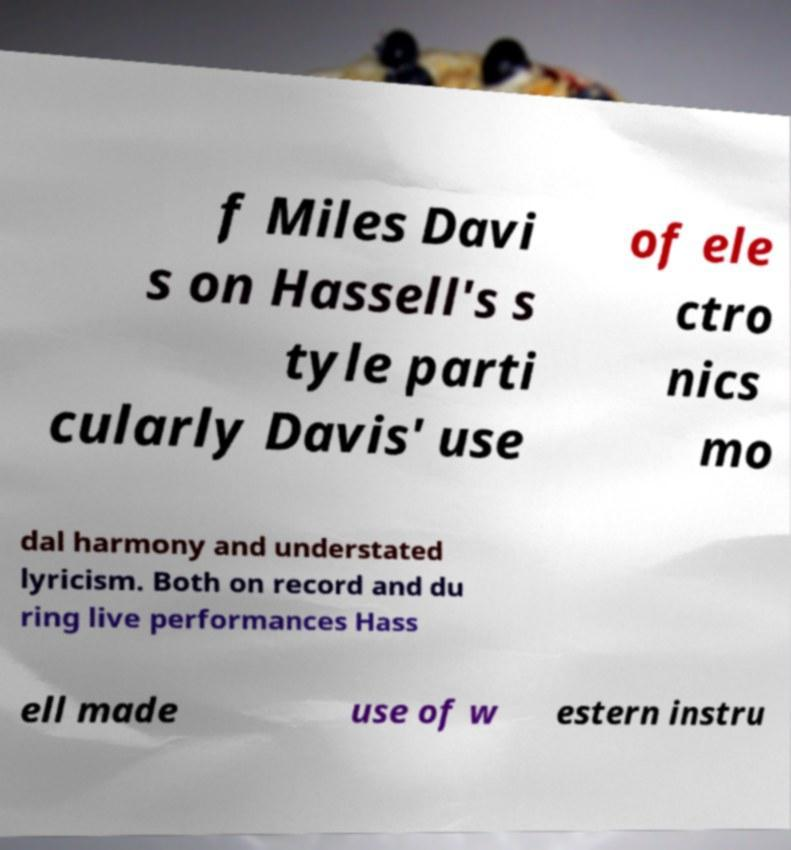Please read and relay the text visible in this image. What does it say? f Miles Davi s on Hassell's s tyle parti cularly Davis' use of ele ctro nics mo dal harmony and understated lyricism. Both on record and du ring live performances Hass ell made use of w estern instru 